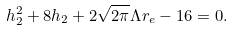<formula> <loc_0><loc_0><loc_500><loc_500>h _ { 2 } ^ { 2 } + 8 h _ { 2 } + 2 \sqrt { 2 \pi } \Lambda r _ { e } - 1 6 = 0 .</formula> 